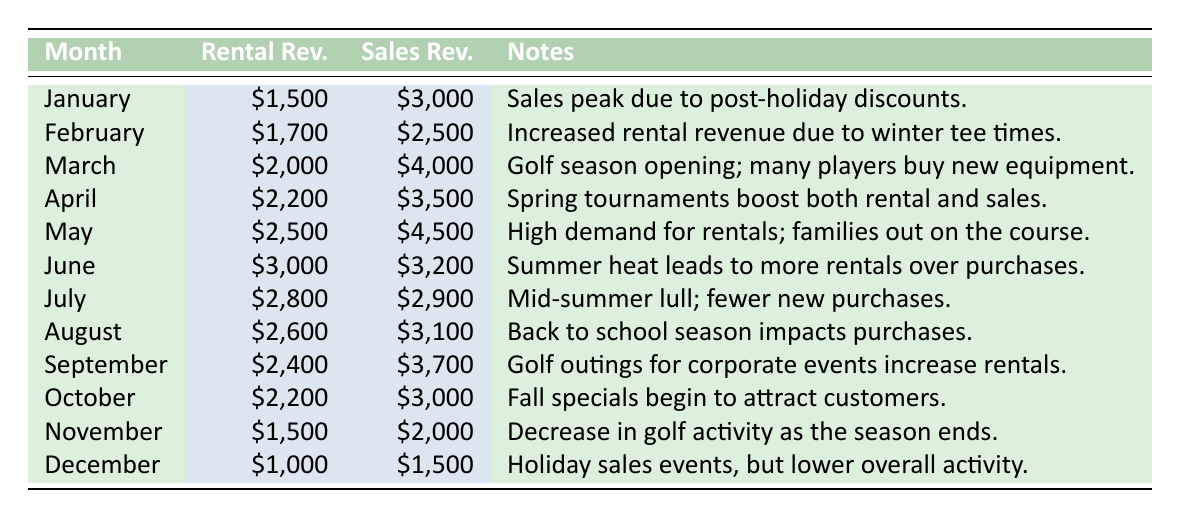What is the rental revenue for June? The table indicates that for June, the rental revenue is listed as 3000.
Answer: 3000 Which month had the highest sales revenue? By checking the sales revenue values of each month, we see that May has the highest sales revenue at 4500.
Answer: May What was the total rental revenue from April to September? To find this, we add the rental revenues for these months: April (2200) + May (2500) + June (3000) + July (2800) + August (2600) + September (2400) = 2200 + 2500 + 3000 + 2800 + 2600 + 2400 = 20500.
Answer: 20500 Is the statement "January had higher rental revenue than November" true? Comparing the rental revenues, January is 1500, and November is 1500 as well; therefore, both are the same, making the statement false.
Answer: No What is the average sales revenue for the months that have more than 3000 in sales? The months with sales revenue over 3000 are March (4000), April (3500), May (4500), September (3700), and August (3100). We calculate the average as (4000 + 3500 + 4500 + 3700 + 3100) / 5 = 3760.
Answer: 3760 Which month experienced a decrease in both rental and sales revenue compared to the previous month? Evaluating the rental and sales revenue month by month, only July shows a decrease in both categories compared to June: rental drops from 3000 to 2800 and sales drop from 3200 to 2900.
Answer: July What is the difference in rental revenue between January and March? The rental revenue for January is 1500 and for March is 2000. To find the difference, we subtract: 2000 - 1500 = 500.
Answer: 500 Which month had lower sales revenue than rental revenue? By comparing each month, we see that in June, rental revenue (3000) exceeded sales revenue (3200); thus, June is the only month where this condition was met.
Answer: June 